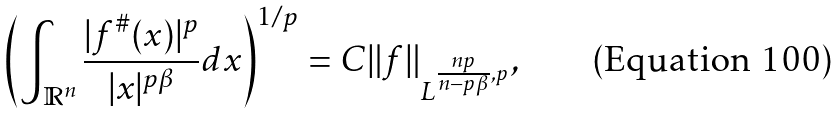Convert formula to latex. <formula><loc_0><loc_0><loc_500><loc_500>\left ( \int _ { \mathbb { R } ^ { n } } \frac { | f ^ { \# } ( x ) | ^ { p } } { | x | ^ { p \beta } } d x \right ) ^ { 1 / p } = C \| f \| _ { L ^ { \frac { n p } { n - p \beta } , p } } ,</formula> 